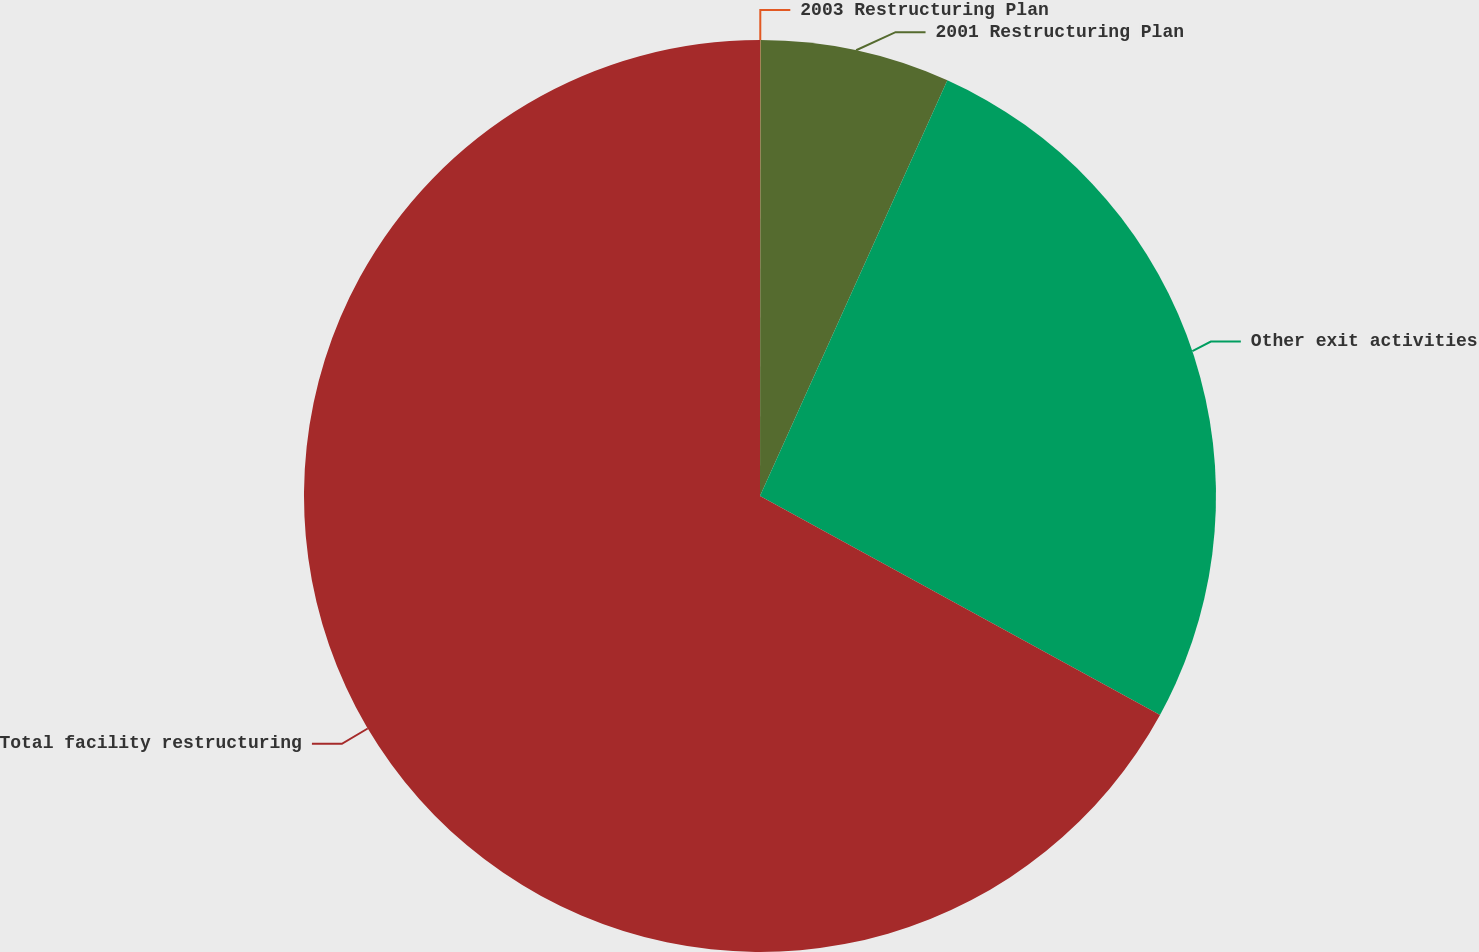Convert chart to OTSL. <chart><loc_0><loc_0><loc_500><loc_500><pie_chart><fcel>2003 Restructuring Plan<fcel>2001 Restructuring Plan<fcel>Other exit activities<fcel>Total facility restructuring<nl><fcel>0.02%<fcel>6.72%<fcel>26.23%<fcel>67.03%<nl></chart> 